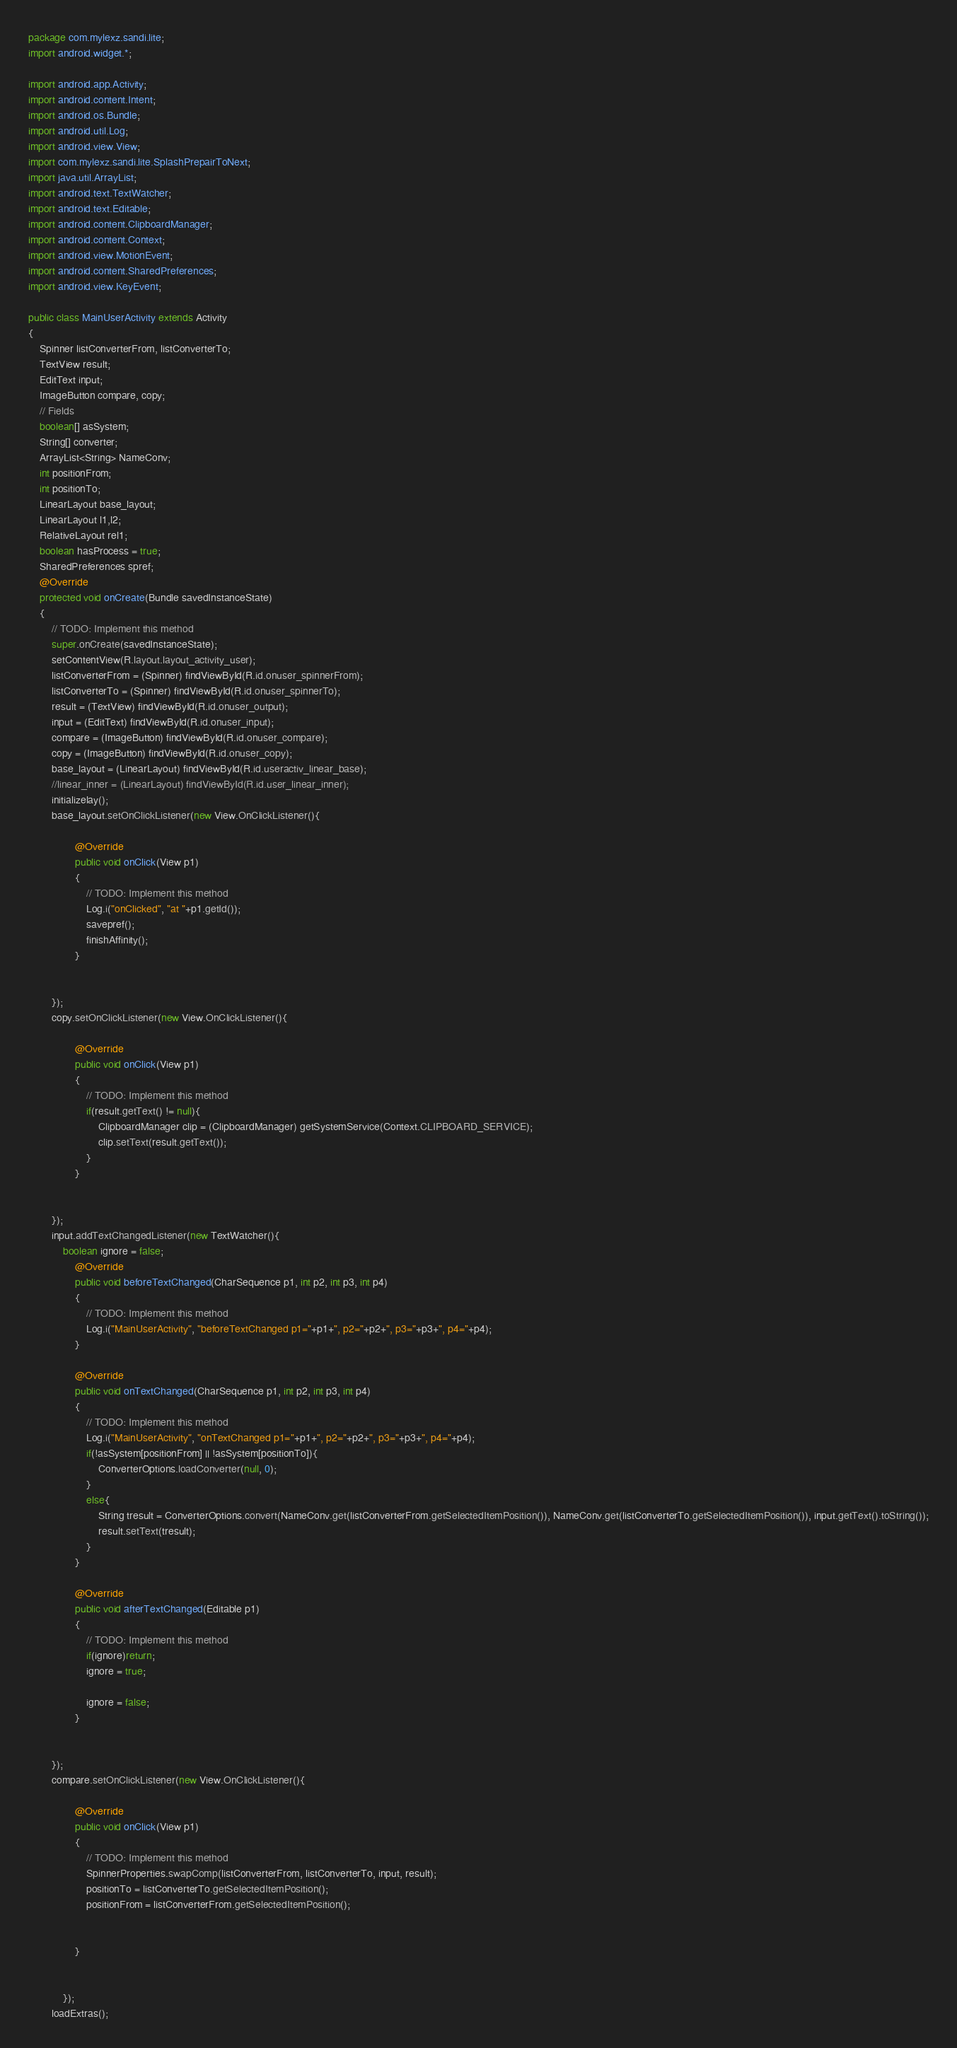Convert code to text. <code><loc_0><loc_0><loc_500><loc_500><_Java_>package com.mylexz.sandi.lite;
import android.widget.*;

import android.app.Activity;
import android.content.Intent;
import android.os.Bundle;
import android.util.Log;
import android.view.View;
import com.mylexz.sandi.lite.SplashPrepairToNext;
import java.util.ArrayList;
import android.text.TextWatcher;
import android.text.Editable;
import android.content.ClipboardManager;
import android.content.Context;
import android.view.MotionEvent;
import android.content.SharedPreferences;
import android.view.KeyEvent;

public class MainUserActivity extends Activity
{
	Spinner listConverterFrom, listConverterTo;
	TextView result;
	EditText input;
	ImageButton compare, copy;
	// Fields
	boolean[] asSystem;
	String[] converter;
	ArrayList<String> NameConv;
	int positionFrom;
	int positionTo;
	LinearLayout base_layout;
	LinearLayout l1,l2;
	RelativeLayout rel1;
	boolean hasProcess = true;
	SharedPreferences spref;
	@Override
	protected void onCreate(Bundle savedInstanceState)
	{
		// TODO: Implement this method
		super.onCreate(savedInstanceState);
		setContentView(R.layout.layout_activity_user);
		listConverterFrom = (Spinner) findViewById(R.id.onuser_spinnerFrom);
		listConverterTo = (Spinner) findViewById(R.id.onuser_spinnerTo);
		result = (TextView) findViewById(R.id.onuser_output);
		input = (EditText) findViewById(R.id.onuser_input);
		compare = (ImageButton) findViewById(R.id.onuser_compare);
		copy = (ImageButton) findViewById(R.id.onuser_copy);
		base_layout = (LinearLayout) findViewById(R.id.useractiv_linear_base);
		//linear_inner = (LinearLayout) findViewById(R.id.user_linear_inner);
		initializelay();
		base_layout.setOnClickListener(new View.OnClickListener(){

				@Override
				public void onClick(View p1)
				{
					// TODO: Implement this method
					Log.i("onClicked", "at "+p1.getId());
					savepref();
					finishAffinity();
				}
				
			
		});
		copy.setOnClickListener(new View.OnClickListener(){

				@Override
				public void onClick(View p1)
				{
					// TODO: Implement this method
					if(result.getText() != null){
						ClipboardManager clip = (ClipboardManager) getSystemService(Context.CLIPBOARD_SERVICE);
						clip.setText(result.getText());
					}
				}
				
			
		});
		input.addTextChangedListener(new TextWatcher(){
			boolean ignore = false;
				@Override
				public void beforeTextChanged(CharSequence p1, int p2, int p3, int p4)
				{
					// TODO: Implement this method
					Log.i("MainUserActivity", "beforeTextChanged p1="+p1+", p2="+p2+", p3="+p3+", p4="+p4);
				}

				@Override
				public void onTextChanged(CharSequence p1, int p2, int p3, int p4)
				{
					// TODO: Implement this method
					Log.i("MainUserActivity", "onTextChanged p1="+p1+", p2="+p2+", p3="+p3+", p4="+p4);
					if(!asSystem[positionFrom] || !asSystem[positionTo]){
						ConverterOptions.loadConverter(null, 0);
					}
					else{
						String tresult = ConverterOptions.convert(NameConv.get(listConverterFrom.getSelectedItemPosition()), NameConv.get(listConverterTo.getSelectedItemPosition()), input.getText().toString());
						result.setText(tresult);
					}
				}

				@Override
				public void afterTextChanged(Editable p1)
				{
					// TODO: Implement this method
					if(ignore)return;
					ignore = true;
					
					ignore = false;
				}
				
			
		});
		compare.setOnClickListener(new View.OnClickListener(){

				@Override
				public void onClick(View p1)
				{
					// TODO: Implement this method
					SpinnerProperties.swapComp(listConverterFrom, listConverterTo, input, result);
					positionTo = listConverterTo.getSelectedItemPosition();
					positionFrom = listConverterFrom.getSelectedItemPosition();


				}


			});
		loadExtras();</code> 